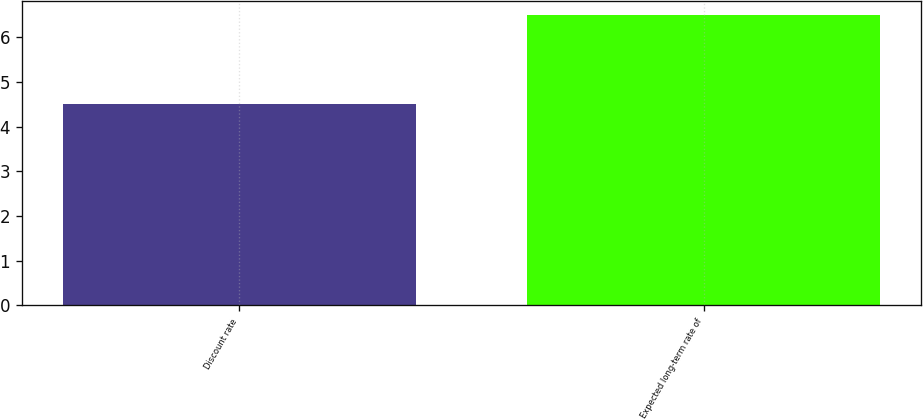Convert chart. <chart><loc_0><loc_0><loc_500><loc_500><bar_chart><fcel>Discount rate<fcel>Expected long-term rate of<nl><fcel>4.5<fcel>6.5<nl></chart> 